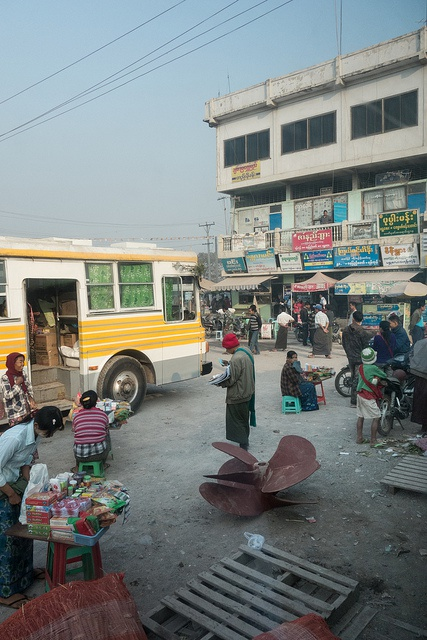Describe the objects in this image and their specific colors. I can see bus in lightblue, ivory, gray, black, and darkgray tones, people in lightblue, black, and gray tones, people in lightblue, black, gray, and darkgray tones, people in lightblue, black, gray, darkgray, and purple tones, and motorcycle in lightblue, black, gray, purple, and darkblue tones in this image. 